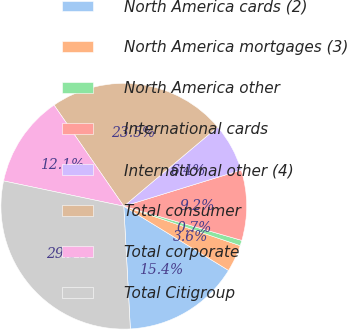<chart> <loc_0><loc_0><loc_500><loc_500><pie_chart><fcel>North America cards (2)<fcel>North America mortgages (3)<fcel>North America other<fcel>International cards<fcel>International other (4)<fcel>Total consumer<fcel>Total corporate<fcel>Total Citigroup<nl><fcel>15.4%<fcel>3.55%<fcel>0.71%<fcel>9.24%<fcel>6.4%<fcel>23.46%<fcel>12.09%<fcel>29.15%<nl></chart> 